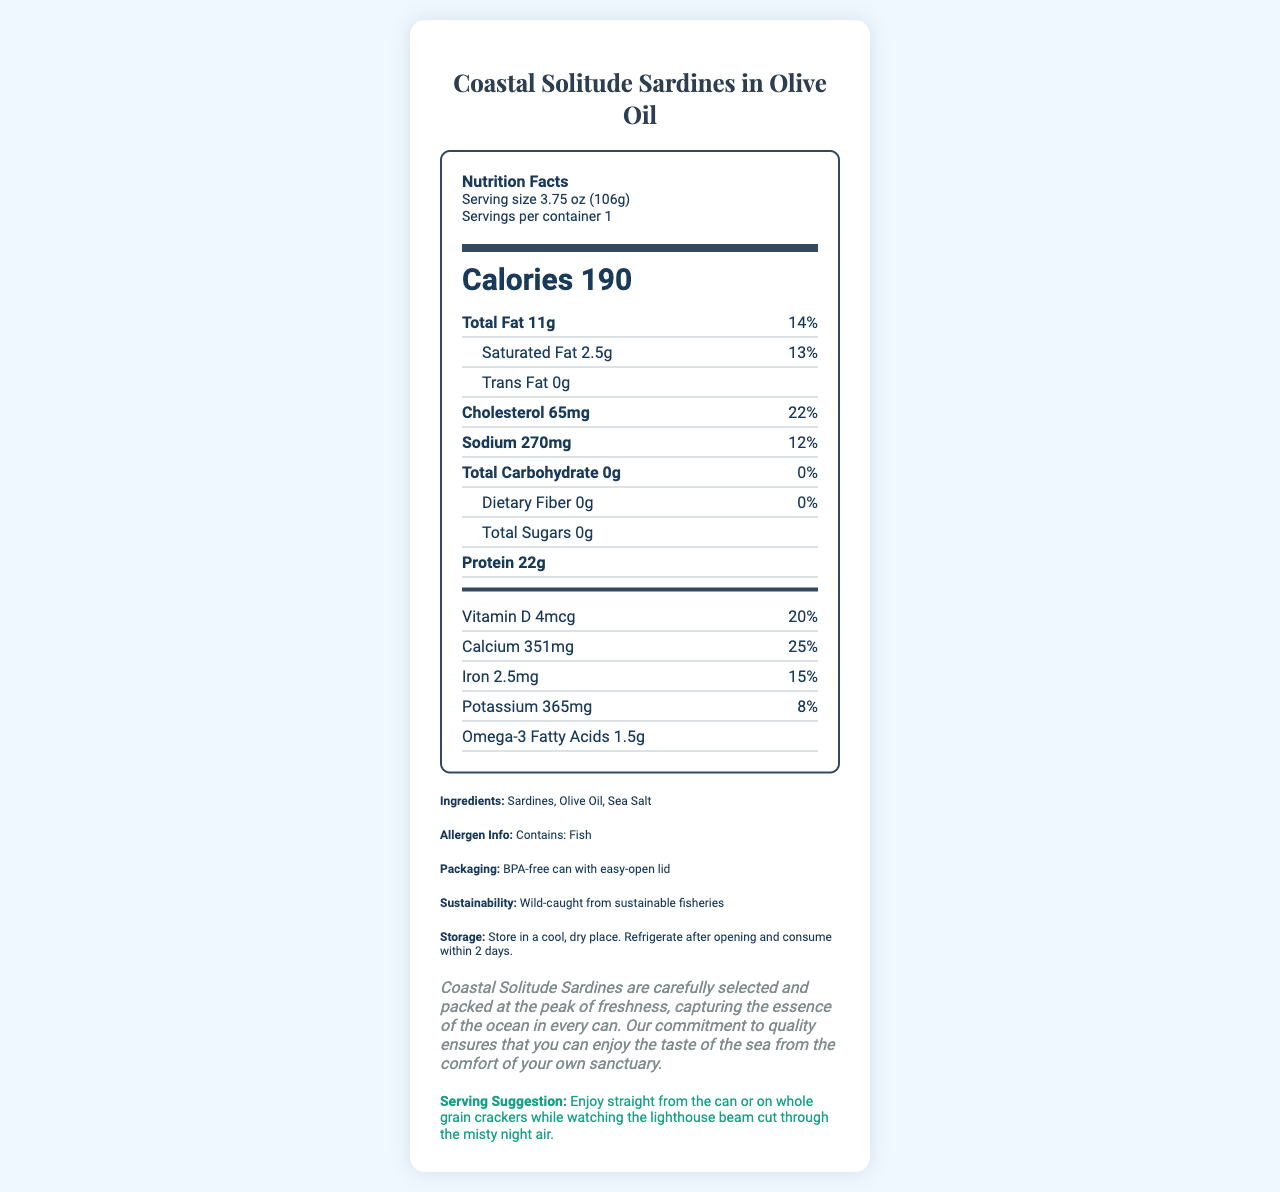What is the serving size for Coastal Solitude Sardines in Olive Oil? The serving size is mentioned at the beginning of the nutrition facts, indicating one serving is 3.75 oz (106g).
Answer: 3.75 oz (106g) How many calories are there per serving? The calories per serving are clearly stated in a prominent part of the nutrition label.
Answer: 190 What percentage of the daily value for calcium does one serving of Coastal Solitude Sardines provide? The nutrition facts label lists calcium as providing 25% of the daily value per serving.
Answer: 25% What is the total fat content in a serving? The total fat content for a serving is shown as 11g in the nutrition facts.
Answer: 11g How many grams of protein are in one serving? The protein amount per serving is listed as 22g.
Answer: 22g Which of the following is an ingredient in Coastal Solitude Sardines? A. Soybean Oil B. Sardines C. Corn Syrup The ingredients list includes Sardines, Olive Oil, and Sea Salt. Only option B is correct.
Answer: B What is the percentage of the daily value of iron in one serving? A. 10% B. 15% C. 20% D. 25% The nutrition facts label lists iron as providing 15% of the daily value per serving.
Answer: B Are the sardines wild-caught from sustainable fisheries? The sustainability information provided in the document confirms that the sardines are wild-caught from sustainable fisheries.
Answer: Yes Summarize the key nutritional and product information of Coastal Solitude Sardines in Olive Oil. The nutrition facts label shows detailed nutritional contributions per serving, focusing on calorie content, macro and micronutrients, and components like calcium and iron. The product's ingredients and emphasis on sustainability, alongside serving suggestions, give a comprehensive view of its qualities.
Answer: Coastal Solitude Sardines in Olive Oil are presented with nutritional details including 190 calories per serving, 11g of total fat, and 22g of protein among other nutrients. The product provides significant amounts of calcium (25% DV) and iron (15% DV), and is made with simple ingredients: sardines, olive oil, and sea salt. Packaged in a BPA-free can, it emphasizes sustainability and is meant to be enjoyed directly from the can or on crackers. What is the recommended storage method for this product upon opening? The document mentions that after opening, the product should be refrigerated and consumed within 2 days.
Answer: Refrigerate after opening and consume within 2 days Based on the serving suggestion, how might one enjoy the sardines while relishing the tranquility of the seaside? The serving suggestion in the document provides this specific scenario for enjoying the sardines.
Answer: Enjoy straight from the can or on whole grain crackers while watching the lighthouse beam cut through the misty night air Where are these sardines sourced from? The document mentions the sustainability of the fishery but does not provide specific sourcing details.
Answer: Cannot be determined What is the allergen information for Coastal Solitude Sardines? The allergen information clearly states that the product contains fish.
Answer: Contains: Fish 